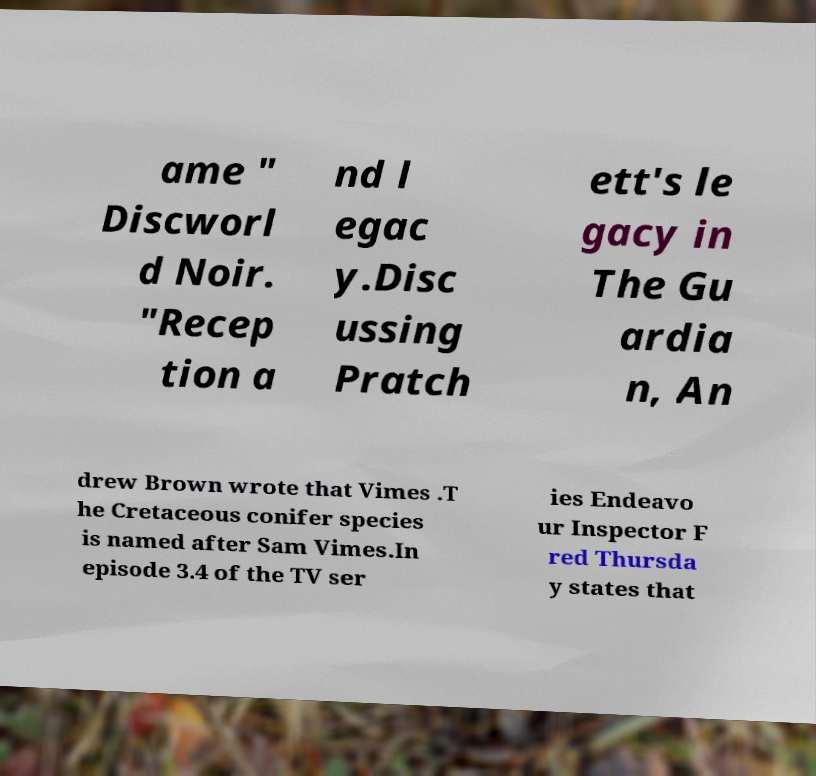Can you read and provide the text displayed in the image?This photo seems to have some interesting text. Can you extract and type it out for me? ame " Discworl d Noir. "Recep tion a nd l egac y.Disc ussing Pratch ett's le gacy in The Gu ardia n, An drew Brown wrote that Vimes .T he Cretaceous conifer species is named after Sam Vimes.In episode 3.4 of the TV ser ies Endeavo ur Inspector F red Thursda y states that 